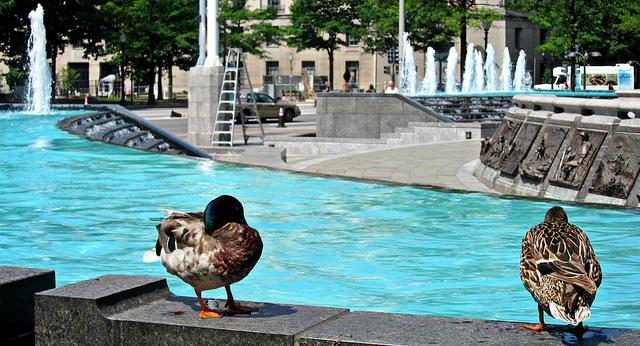Why are they here? to swim 